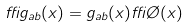<formula> <loc_0><loc_0><loc_500><loc_500>\delta g _ { a b } ( x ) = g _ { a b } ( x ) \delta \chi ( x )</formula> 